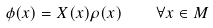Convert formula to latex. <formula><loc_0><loc_0><loc_500><loc_500>\phi ( x ) = X ( x ) \rho ( x ) \quad \forall x \in M</formula> 